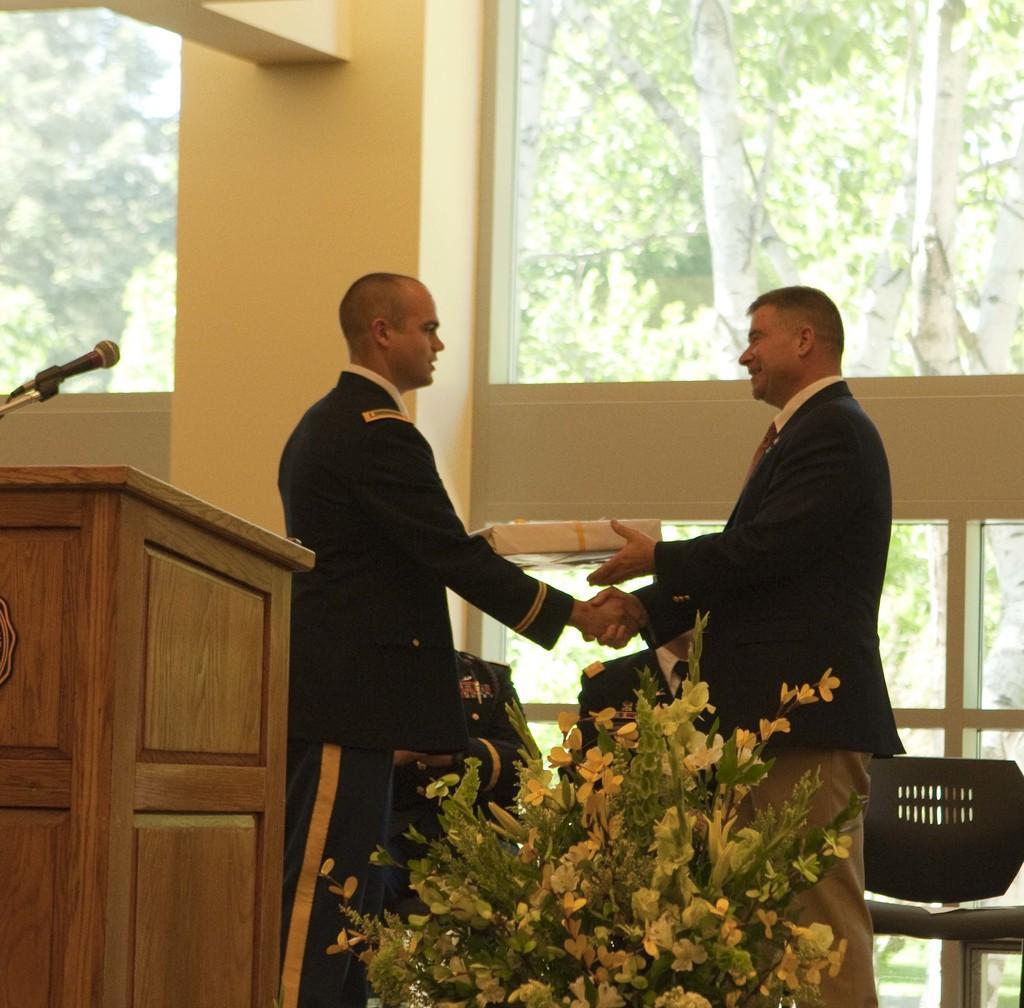Can you describe this image briefly? In this image we can see two men are standing. They are wearing uniforms. At the bottom of the image, we can see the flowers. We can see a podium and the mic on the left side of the image. Behind the men, we can see two men are sitting on the chairs. In the background, we can see a wall and glasses. Behind the glasses, we can see the trees. 